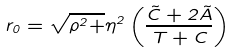<formula> <loc_0><loc_0><loc_500><loc_500>r _ { 0 } = \sqrt { \rho ^ { 2 } + } \eta ^ { 2 } \left ( \frac { \tilde { C } + 2 \tilde { A } } { T + C } \right )</formula> 